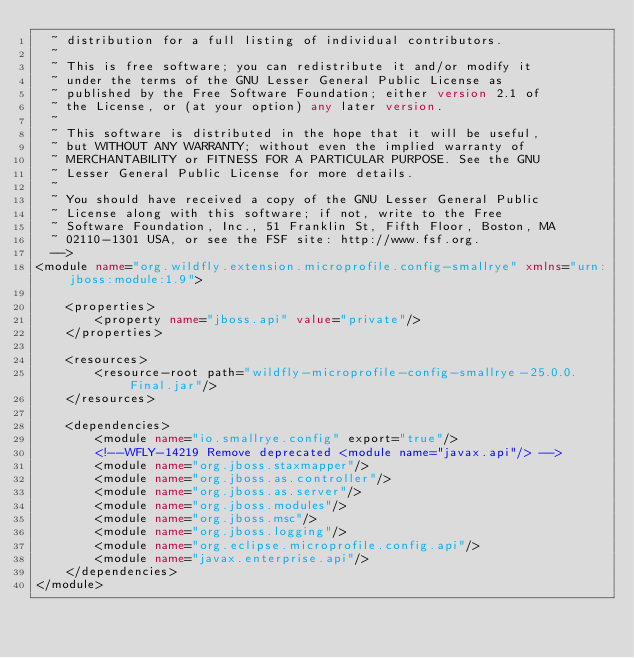<code> <loc_0><loc_0><loc_500><loc_500><_XML_>  ~ distribution for a full listing of individual contributors.
  ~
  ~ This is free software; you can redistribute it and/or modify it
  ~ under the terms of the GNU Lesser General Public License as
  ~ published by the Free Software Foundation; either version 2.1 of
  ~ the License, or (at your option) any later version.
  ~
  ~ This software is distributed in the hope that it will be useful,
  ~ but WITHOUT ANY WARRANTY; without even the implied warranty of
  ~ MERCHANTABILITY or FITNESS FOR A PARTICULAR PURPOSE. See the GNU
  ~ Lesser General Public License for more details.
  ~
  ~ You should have received a copy of the GNU Lesser General Public
  ~ License along with this software; if not, write to the Free
  ~ Software Foundation, Inc., 51 Franklin St, Fifth Floor, Boston, MA
  ~ 02110-1301 USA, or see the FSF site: http://www.fsf.org.
  -->
<module name="org.wildfly.extension.microprofile.config-smallrye" xmlns="urn:jboss:module:1.9">

    <properties>
        <property name="jboss.api" value="private"/>
    </properties>

    <resources>
        <resource-root path="wildfly-microprofile-config-smallrye-25.0.0.Final.jar"/>
    </resources>

    <dependencies>
        <module name="io.smallrye.config" export="true"/>
        <!--WFLY-14219 Remove deprecated <module name="javax.api"/> -->
        <module name="org.jboss.staxmapper"/>
        <module name="org.jboss.as.controller"/>
        <module name="org.jboss.as.server"/>
        <module name="org.jboss.modules"/>
        <module name="org.jboss.msc"/>
        <module name="org.jboss.logging"/>
        <module name="org.eclipse.microprofile.config.api"/>
        <module name="javax.enterprise.api"/>
    </dependencies>
</module>
</code> 